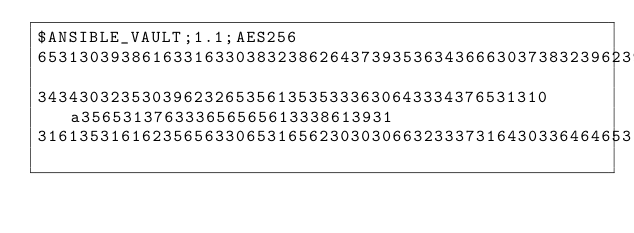<code> <loc_0><loc_0><loc_500><loc_500><_YAML_>$ANSIBLE_VAULT;1.1;AES256
65313039386163316330383238626437393536343666303738323962393339663032303864653963
3434303235303962326535613535333630643334376531310a356531376333656565613338613931
31613531616235656330653165623030306632333731643033646465316461343966363562376639</code> 